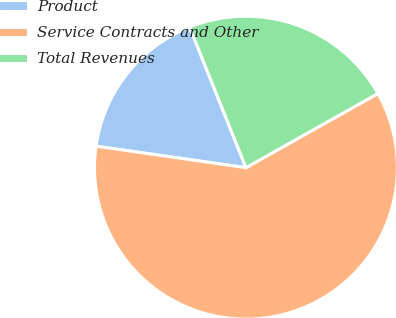<chart> <loc_0><loc_0><loc_500><loc_500><pie_chart><fcel>Product<fcel>Service Contracts and Other<fcel>Total Revenues<nl><fcel>16.67%<fcel>60.42%<fcel>22.92%<nl></chart> 